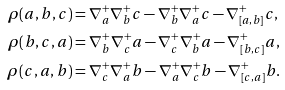<formula> <loc_0><loc_0><loc_500><loc_500>\rho ( a , b , c ) & = \nabla _ { a } ^ { + } \nabla _ { b } ^ { + } c - \nabla _ { b } ^ { + } \nabla _ { a } ^ { + } c - \nabla _ { [ a , b ] } ^ { + } c , \\ \rho ( b , c , a ) & = \nabla _ { b } ^ { + } \nabla _ { c } ^ { + } a - \nabla _ { c } ^ { + } \nabla _ { b } ^ { + } a - \nabla _ { [ b , c ] } ^ { + } a , \\ \rho ( c , a , b ) & = \nabla _ { c } ^ { + } \nabla _ { a } ^ { + } b - \nabla _ { a } ^ { + } \nabla _ { c } ^ { + } b - \nabla _ { [ c , a ] } ^ { + } b .</formula> 